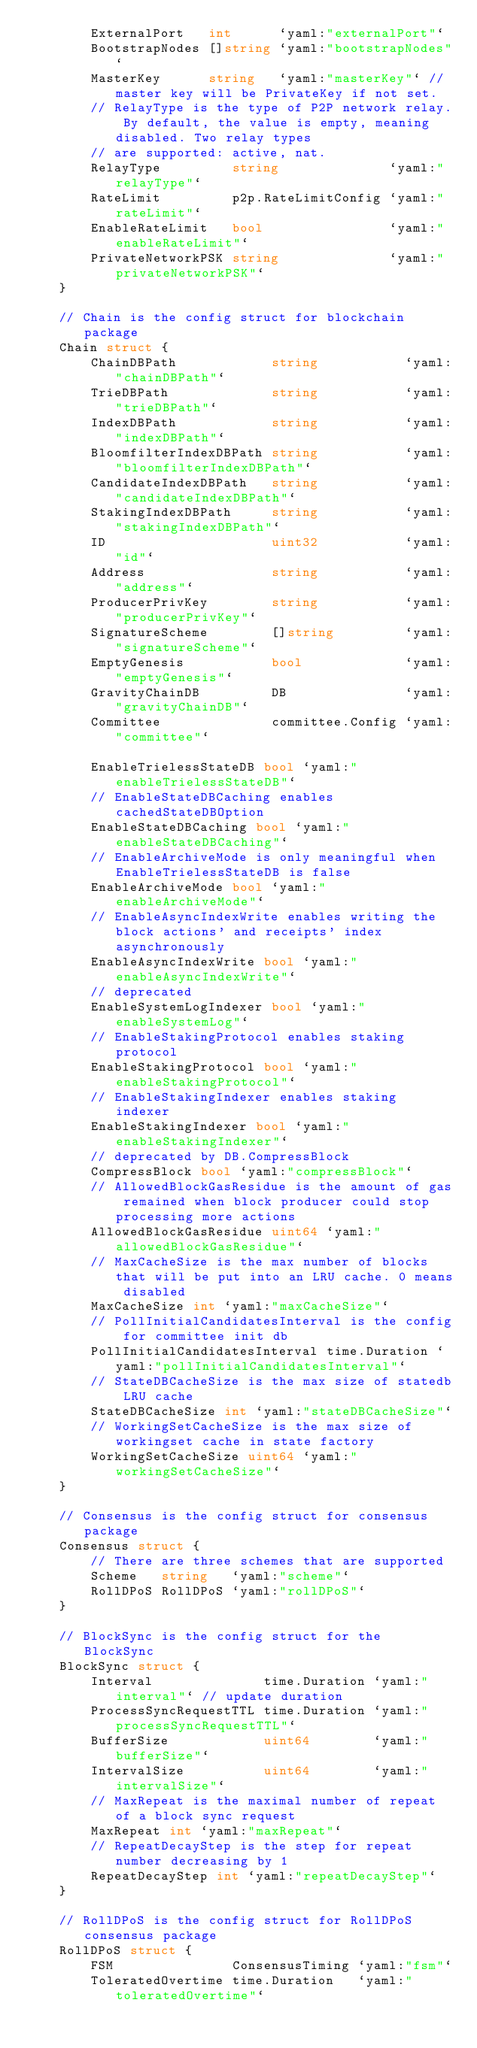<code> <loc_0><loc_0><loc_500><loc_500><_Go_>		ExternalPort   int      `yaml:"externalPort"`
		BootstrapNodes []string `yaml:"bootstrapNodes"`
		MasterKey      string   `yaml:"masterKey"` // master key will be PrivateKey if not set.
		// RelayType is the type of P2P network relay. By default, the value is empty, meaning disabled. Two relay types
		// are supported: active, nat.
		RelayType         string              `yaml:"relayType"`
		RateLimit         p2p.RateLimitConfig `yaml:"rateLimit"`
		EnableRateLimit   bool                `yaml:"enableRateLimit"`
		PrivateNetworkPSK string              `yaml:"privateNetworkPSK"`
	}

	// Chain is the config struct for blockchain package
	Chain struct {
		ChainDBPath            string           `yaml:"chainDBPath"`
		TrieDBPath             string           `yaml:"trieDBPath"`
		IndexDBPath            string           `yaml:"indexDBPath"`
		BloomfilterIndexDBPath string           `yaml:"bloomfilterIndexDBPath"`
		CandidateIndexDBPath   string           `yaml:"candidateIndexDBPath"`
		StakingIndexDBPath     string           `yaml:"stakingIndexDBPath"`
		ID                     uint32           `yaml:"id"`
		Address                string           `yaml:"address"`
		ProducerPrivKey        string           `yaml:"producerPrivKey"`
		SignatureScheme        []string         `yaml:"signatureScheme"`
		EmptyGenesis           bool             `yaml:"emptyGenesis"`
		GravityChainDB         DB               `yaml:"gravityChainDB"`
		Committee              committee.Config `yaml:"committee"`

		EnableTrielessStateDB bool `yaml:"enableTrielessStateDB"`
		// EnableStateDBCaching enables cachedStateDBOption
		EnableStateDBCaching bool `yaml:"enableStateDBCaching"`
		// EnableArchiveMode is only meaningful when EnableTrielessStateDB is false
		EnableArchiveMode bool `yaml:"enableArchiveMode"`
		// EnableAsyncIndexWrite enables writing the block actions' and receipts' index asynchronously
		EnableAsyncIndexWrite bool `yaml:"enableAsyncIndexWrite"`
		// deprecated
		EnableSystemLogIndexer bool `yaml:"enableSystemLog"`
		// EnableStakingProtocol enables staking protocol
		EnableStakingProtocol bool `yaml:"enableStakingProtocol"`
		// EnableStakingIndexer enables staking indexer
		EnableStakingIndexer bool `yaml:"enableStakingIndexer"`
		// deprecated by DB.CompressBlock
		CompressBlock bool `yaml:"compressBlock"`
		// AllowedBlockGasResidue is the amount of gas remained when block producer could stop processing more actions
		AllowedBlockGasResidue uint64 `yaml:"allowedBlockGasResidue"`
		// MaxCacheSize is the max number of blocks that will be put into an LRU cache. 0 means disabled
		MaxCacheSize int `yaml:"maxCacheSize"`
		// PollInitialCandidatesInterval is the config for committee init db
		PollInitialCandidatesInterval time.Duration `yaml:"pollInitialCandidatesInterval"`
		// StateDBCacheSize is the max size of statedb LRU cache
		StateDBCacheSize int `yaml:"stateDBCacheSize"`
		// WorkingSetCacheSize is the max size of workingset cache in state factory
		WorkingSetCacheSize uint64 `yaml:"workingSetCacheSize"`
	}

	// Consensus is the config struct for consensus package
	Consensus struct {
		// There are three schemes that are supported
		Scheme   string   `yaml:"scheme"`
		RollDPoS RollDPoS `yaml:"rollDPoS"`
	}

	// BlockSync is the config struct for the BlockSync
	BlockSync struct {
		Interval              time.Duration `yaml:"interval"` // update duration
		ProcessSyncRequestTTL time.Duration `yaml:"processSyncRequestTTL"`
		BufferSize            uint64        `yaml:"bufferSize"`
		IntervalSize          uint64        `yaml:"intervalSize"`
		// MaxRepeat is the maximal number of repeat of a block sync request
		MaxRepeat int `yaml:"maxRepeat"`
		// RepeatDecayStep is the step for repeat number decreasing by 1
		RepeatDecayStep int `yaml:"repeatDecayStep"`
	}

	// RollDPoS is the config struct for RollDPoS consensus package
	RollDPoS struct {
		FSM               ConsensusTiming `yaml:"fsm"`
		ToleratedOvertime time.Duration   `yaml:"toleratedOvertime"`</code> 